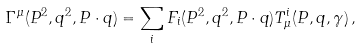<formula> <loc_0><loc_0><loc_500><loc_500>\Gamma ^ { \mu } ( P ^ { 2 } , q ^ { 2 } , P \cdot q ) = \sum _ { i } F _ { i } ( P ^ { 2 } , q ^ { 2 } , P \cdot q ) T _ { \mu } ^ { i } ( P , q , \gamma ) \, ,</formula> 